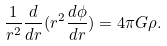Convert formula to latex. <formula><loc_0><loc_0><loc_500><loc_500>\frac { 1 } { r ^ { 2 } } \frac { d } { d r } ( r ^ { 2 } \frac { d \phi } { d r } ) = 4 \pi G \rho .</formula> 